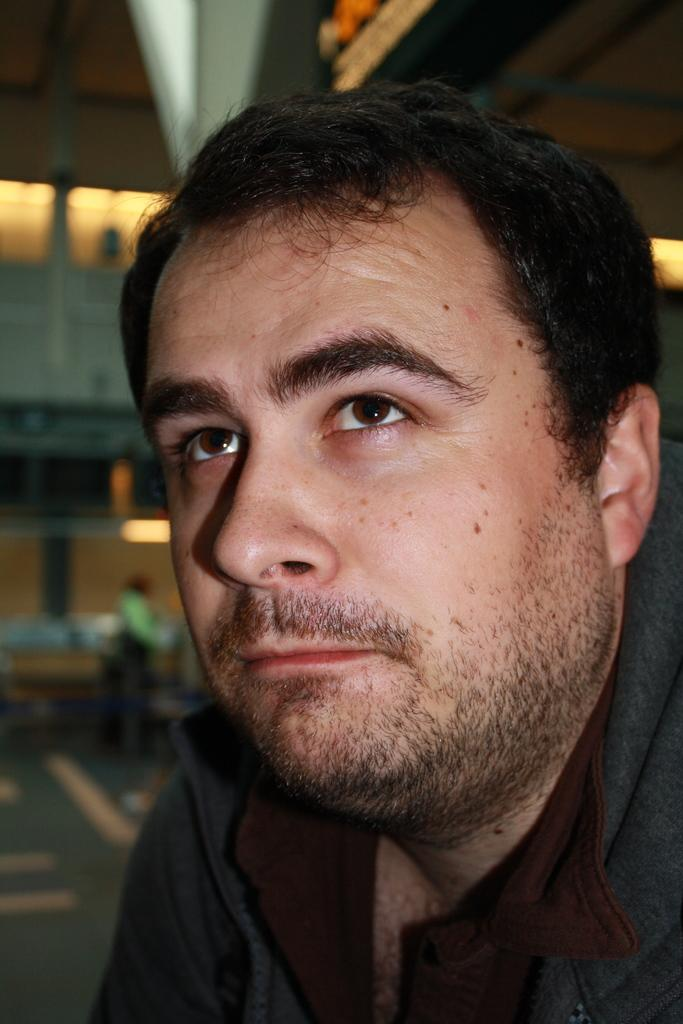What is the person in the image wearing? The person in the image is wearing a black and brown color dress. Can you describe the background of the image? The background of the image is blurred. What type of argument is the person having with the yarn in the image? There is no yarn or argument present in the image. 